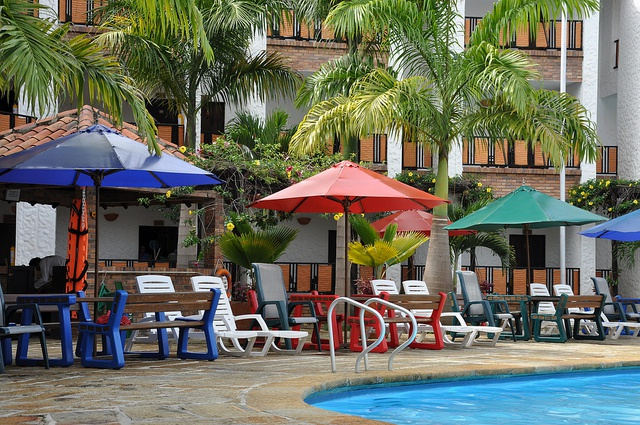Describe the objects in this image and their specific colors. I can see chair in black, gray, and maroon tones, umbrella in black, darkblue, and gray tones, bench in black, maroon, navy, and gray tones, umbrella in black, lightpink, brown, salmon, and maroon tones, and umbrella in black, teal, and lightblue tones in this image. 